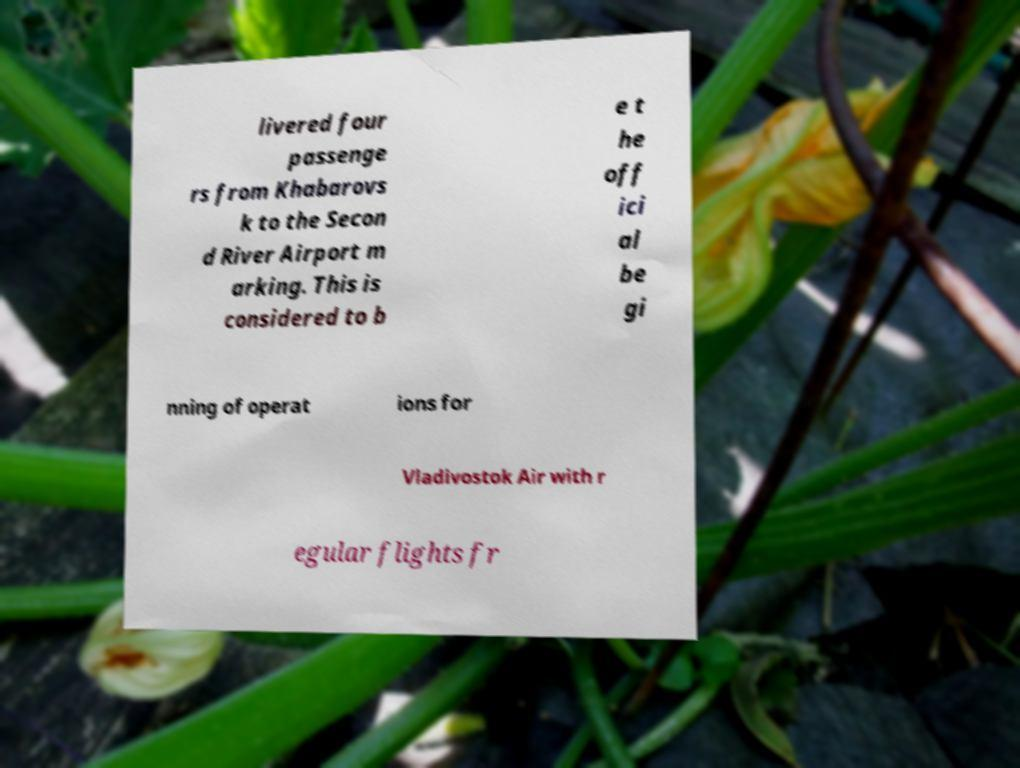Can you accurately transcribe the text from the provided image for me? livered four passenge rs from Khabarovs k to the Secon d River Airport m arking. This is considered to b e t he off ici al be gi nning of operat ions for Vladivostok Air with r egular flights fr 